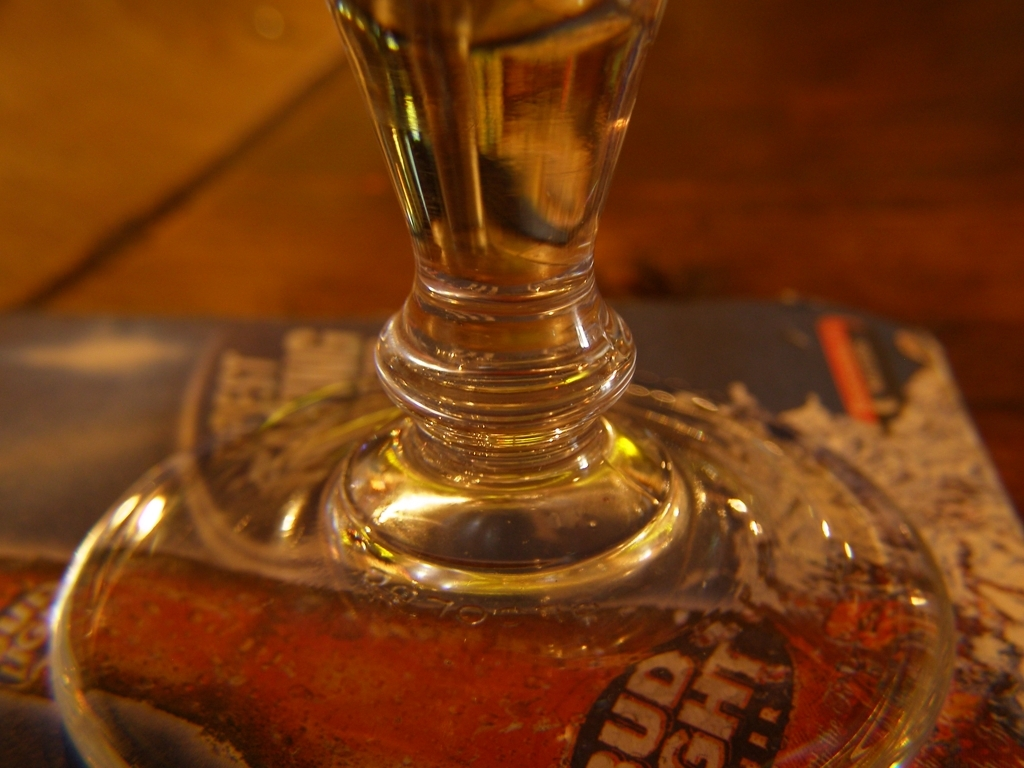Is the lighting in the environment inappropriate? The lighting in the image appears to create a warm, intimate atmosphere, highlighting the texture and contours of the glass object. Although the lighting is moody and may not be suitable for all tasks, it does not seem to be inappropriate for the setting. Elements in the background suggest a cozy environment, possibly a bar or restaurant, where dim lighting is often desirable. 